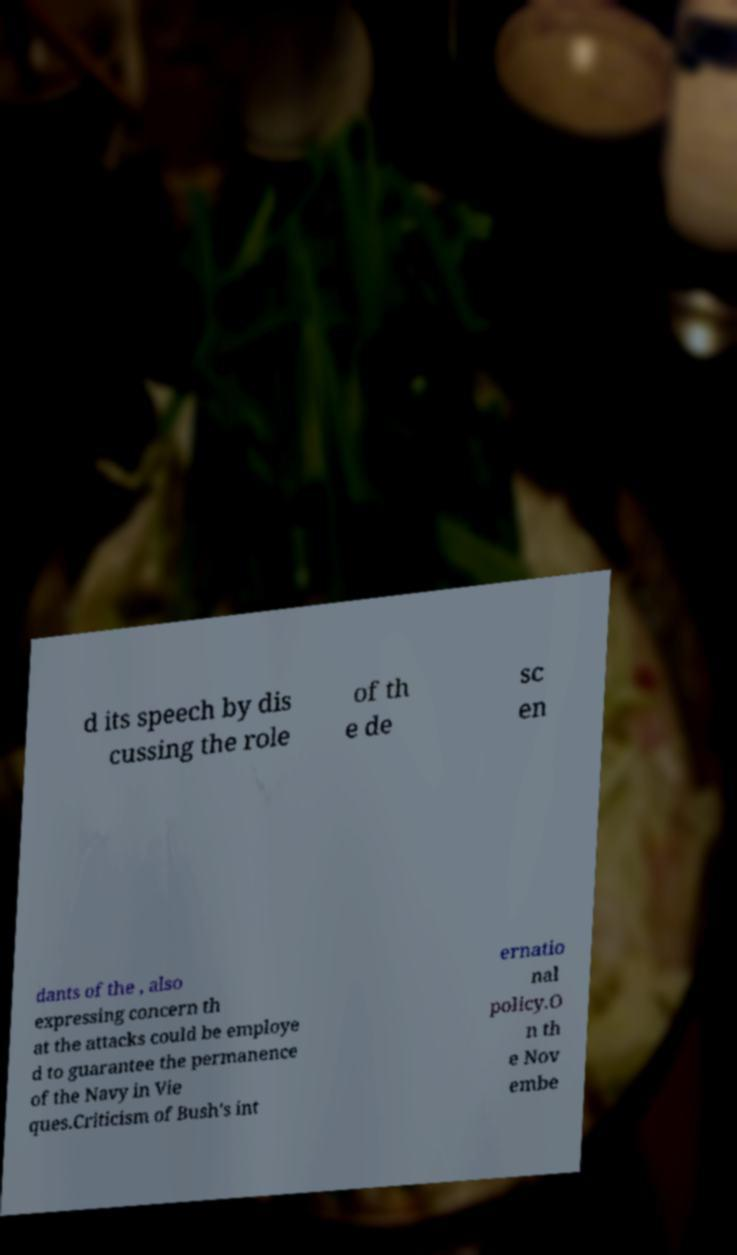Can you read and provide the text displayed in the image?This photo seems to have some interesting text. Can you extract and type it out for me? d its speech by dis cussing the role of th e de sc en dants of the , also expressing concern th at the attacks could be employe d to guarantee the permanence of the Navy in Vie ques.Criticism of Bush's int ernatio nal policy.O n th e Nov embe 